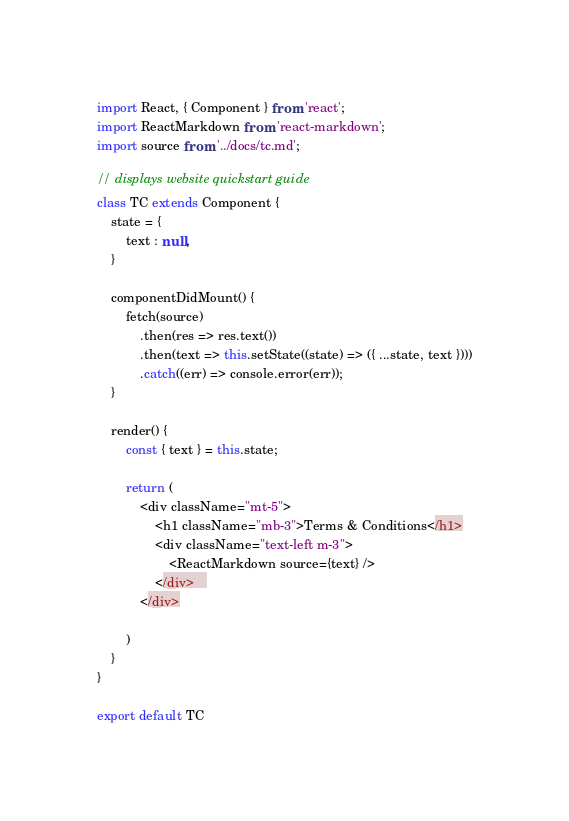Convert code to text. <code><loc_0><loc_0><loc_500><loc_500><_JavaScript_>import React, { Component } from 'react';
import ReactMarkdown from 'react-markdown';
import source from '../docs/tc.md';

// displays website quickstart guide
class TC extends Component {
    state = {
        text : null,
    }

    componentDidMount() {
        fetch(source)
            .then(res => res.text())
            .then(text => this.setState((state) => ({ ...state, text })))
            .catch((err) => console.error(err));
    }

    render() {
        const { text } = this.state;

        return (
            <div className="mt-5">
                <h1 className="mb-3">Terms & Conditions</h1>
                <div className="text-left m-3">
                    <ReactMarkdown source={text} />
                </div>   
            </div>
            
        )
    }
}

export default TC</code> 